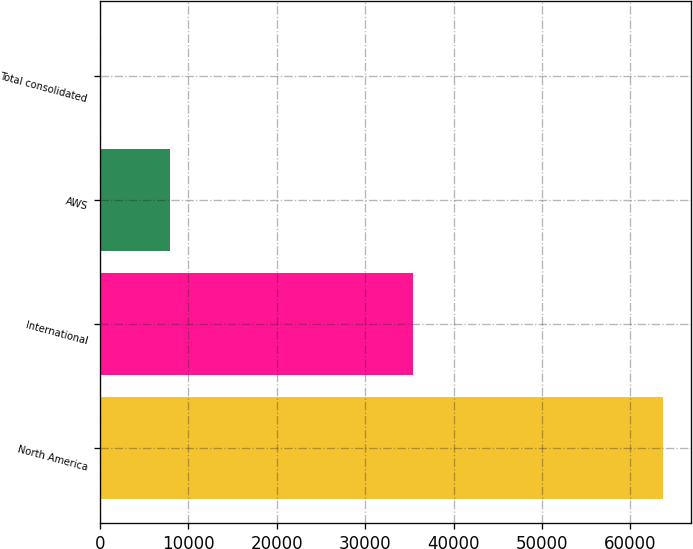<chart> <loc_0><loc_0><loc_500><loc_500><bar_chart><fcel>North America<fcel>International<fcel>AWS<fcel>Total consolidated<nl><fcel>63708<fcel>35418<fcel>7880<fcel>20<nl></chart> 